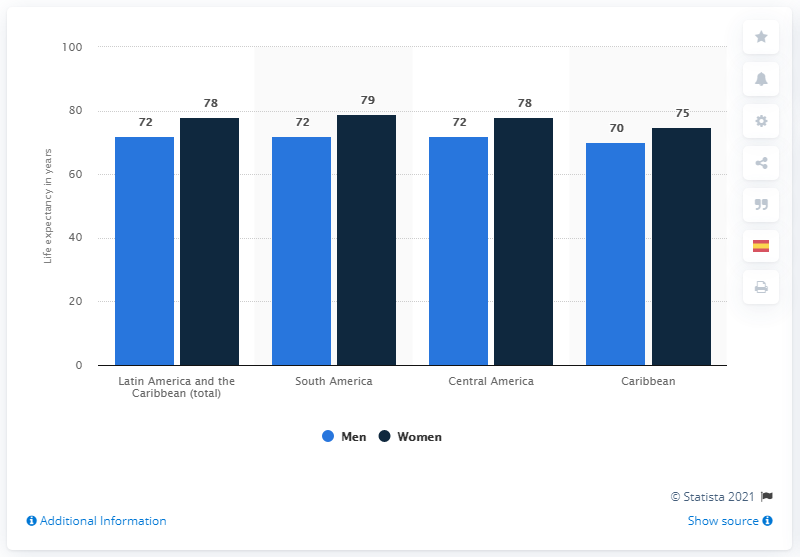Point out several critical features in this image. The highest value in the chart is 79. The chart shows a range of values for a particular metric, with the lowest value being 70. 